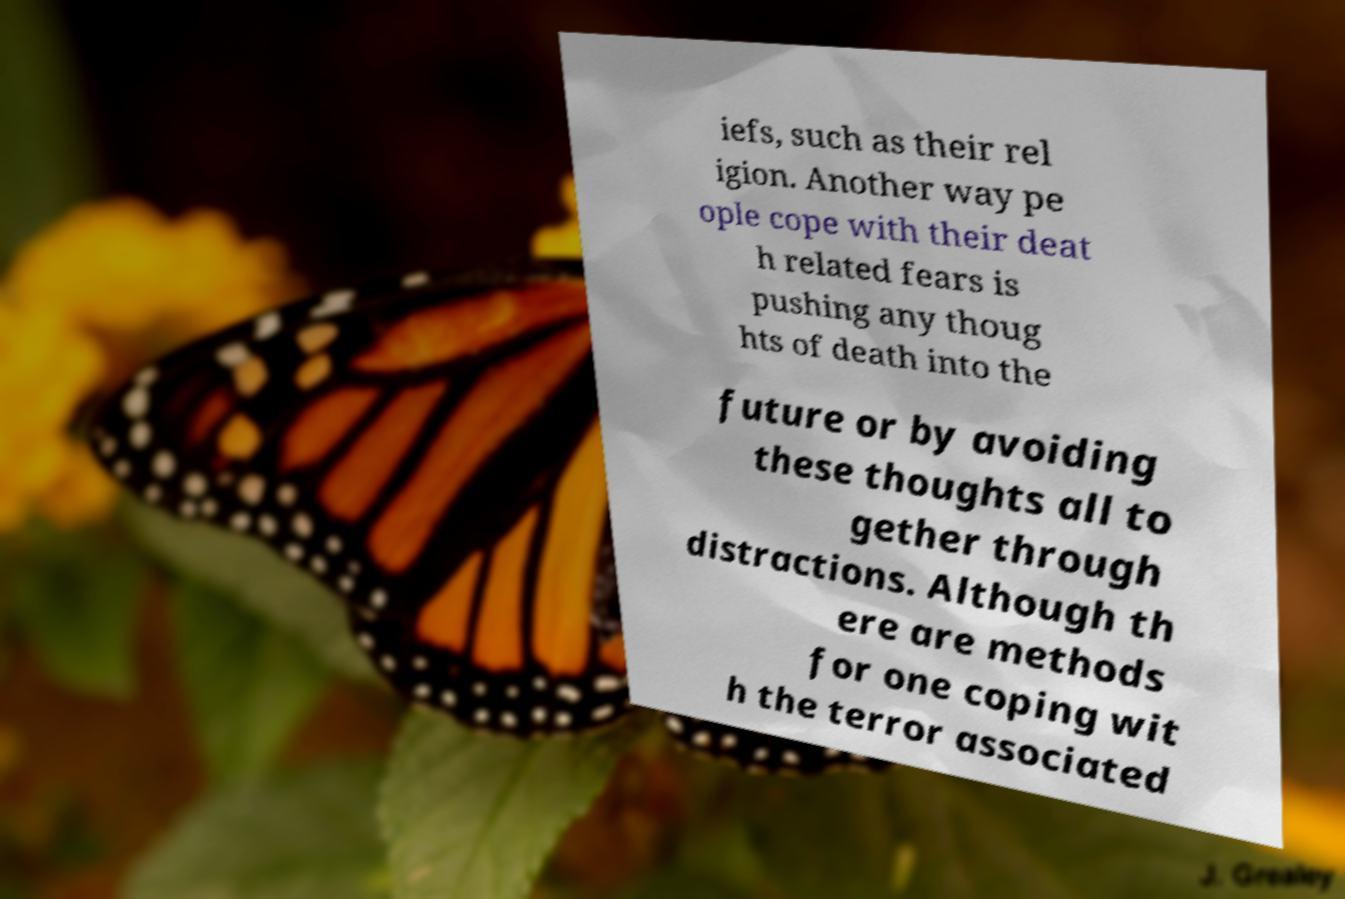There's text embedded in this image that I need extracted. Can you transcribe it verbatim? iefs, such as their rel igion. Another way pe ople cope with their deat h related fears is pushing any thoug hts of death into the future or by avoiding these thoughts all to gether through distractions. Although th ere are methods for one coping wit h the terror associated 